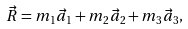<formula> <loc_0><loc_0><loc_500><loc_500>\vec { R } = m _ { 1 } \vec { a } _ { 1 } + m _ { 2 } \vec { a } _ { 2 } + m _ { 3 } \vec { a } _ { 3 } ,</formula> 